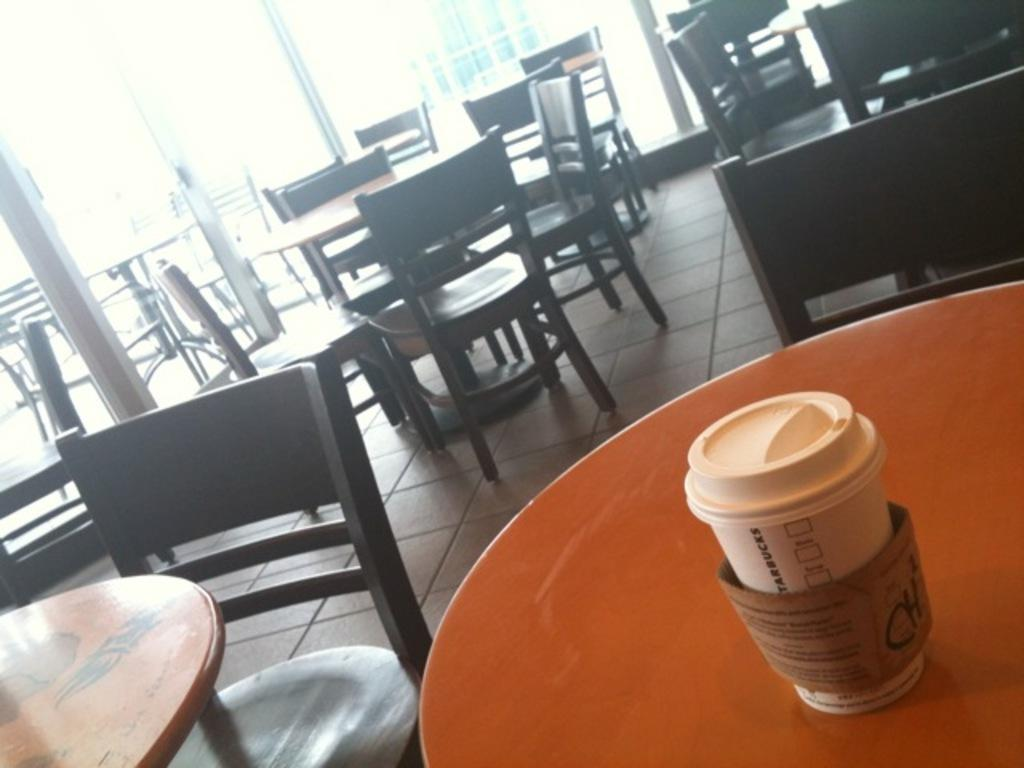What type of furniture is present in the image? There are chairs in the image. How are the chairs arranged in relation to each other? The chairs are arranged around a table. What can be found on the table in the image? There is a cup on the table. What type of establishment might the setting in the image resemble? The setting resembles a coffee shop. How many trains can be seen passing by in the image? There are no trains visible in the image. What is the range of the motion sensor in the image? There is no mention of a motion sensor in the image. 